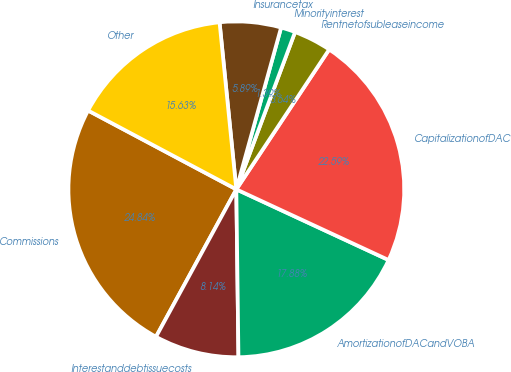<chart> <loc_0><loc_0><loc_500><loc_500><pie_chart><fcel>Commissions<fcel>Interestanddebtissuecosts<fcel>AmortizationofDACandVOBA<fcel>CapitalizationofDAC<fcel>Rentnetofsubleaseincome<fcel>Minorityinterest<fcel>Insurancetax<fcel>Other<nl><fcel>24.84%<fcel>8.14%<fcel>17.88%<fcel>22.59%<fcel>3.64%<fcel>1.39%<fcel>5.89%<fcel>15.63%<nl></chart> 